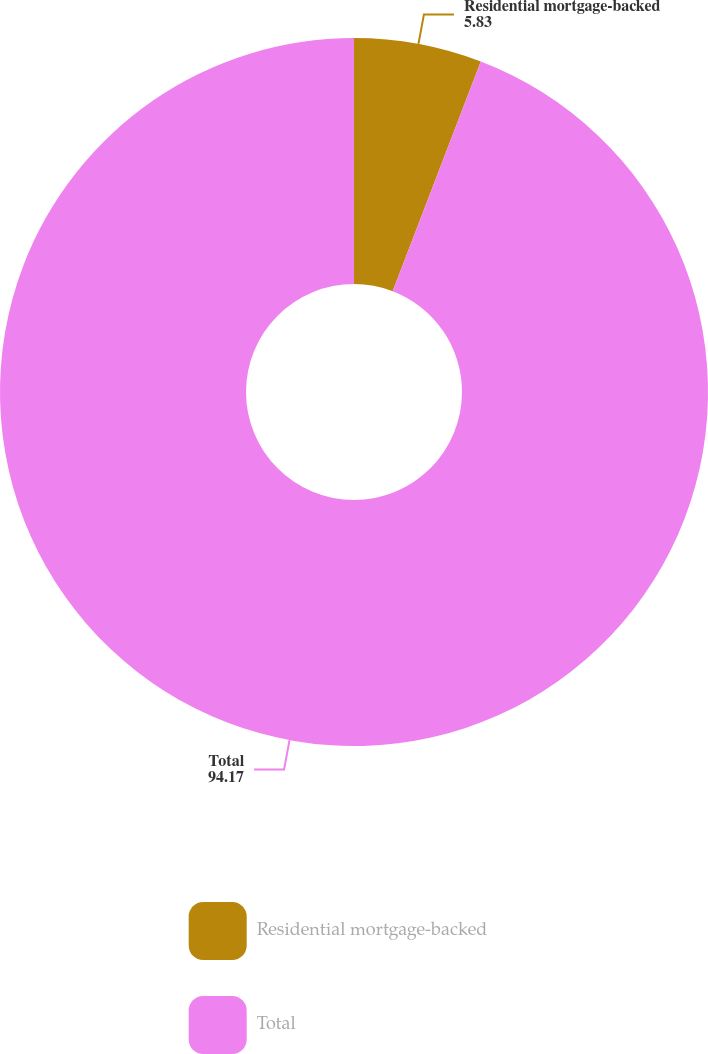Convert chart to OTSL. <chart><loc_0><loc_0><loc_500><loc_500><pie_chart><fcel>Residential mortgage-backed<fcel>Total<nl><fcel>5.83%<fcel>94.17%<nl></chart> 